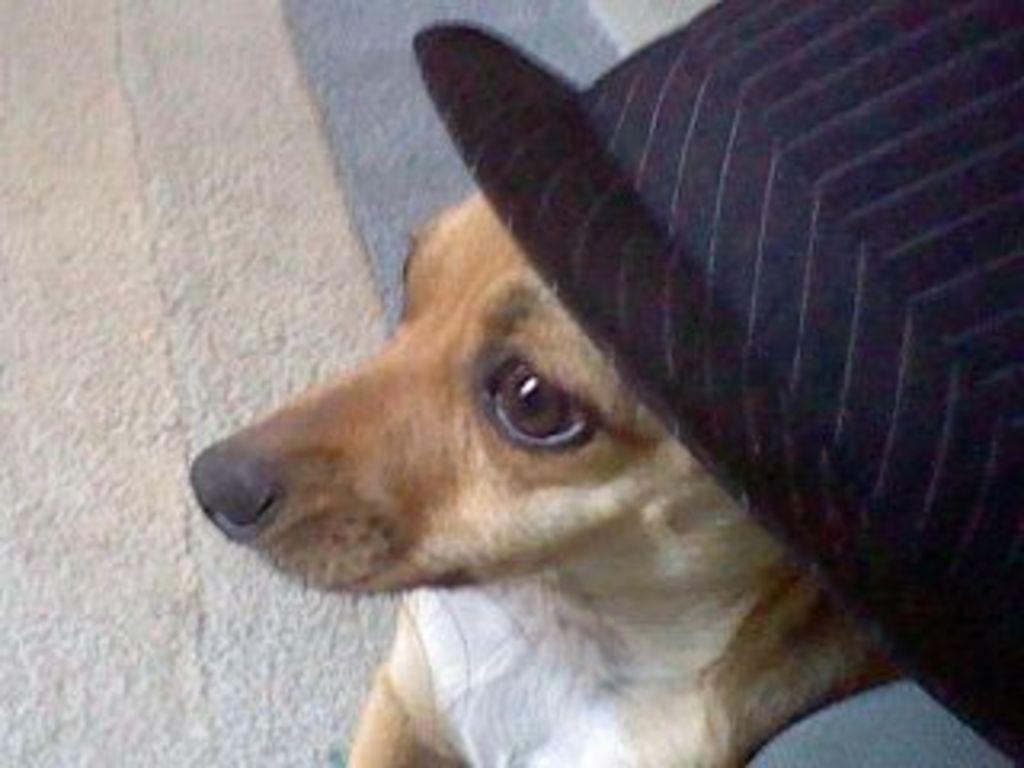Describe this image in one or two sentences. In the picture we can see dog which is brown in color and there is black color hat. 